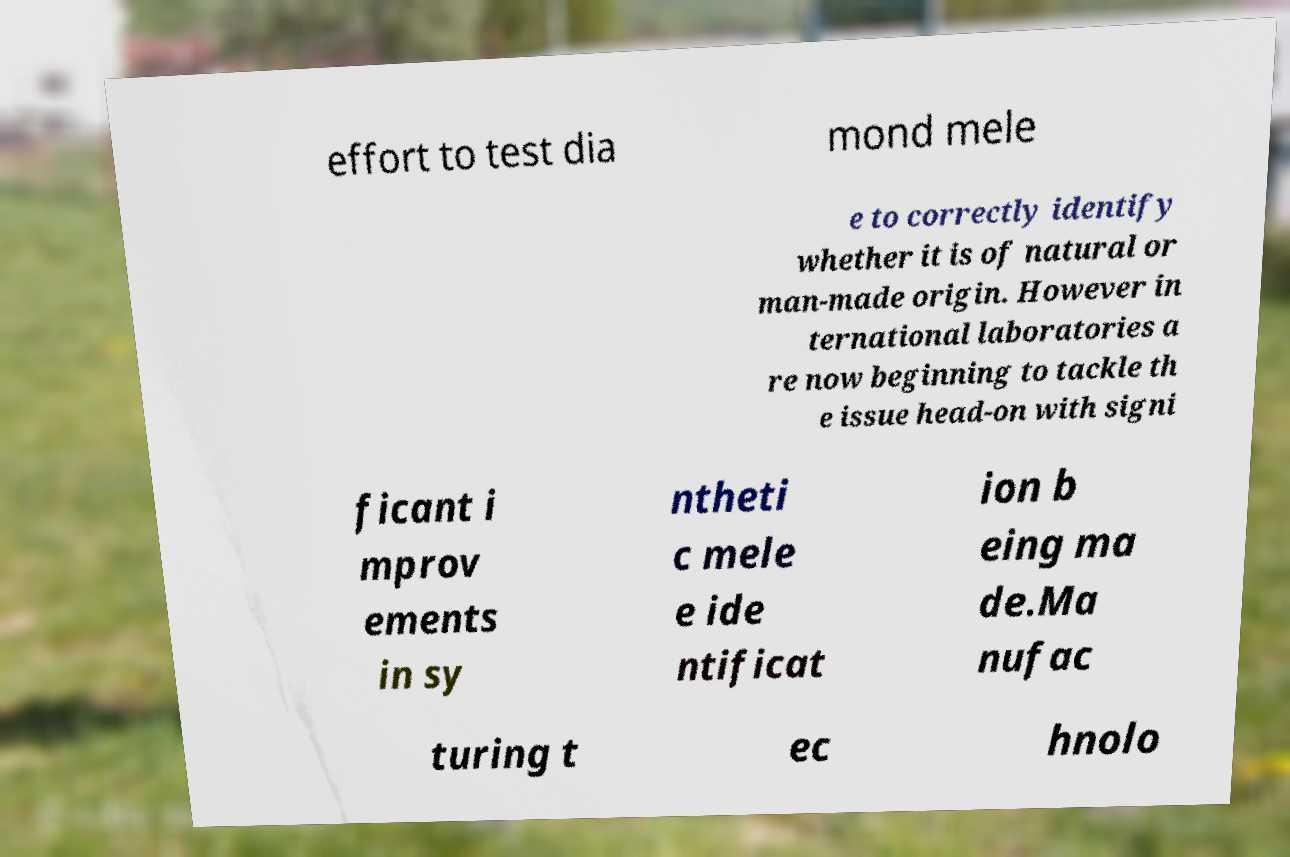Please identify and transcribe the text found in this image. effort to test dia mond mele e to correctly identify whether it is of natural or man-made origin. However in ternational laboratories a re now beginning to tackle th e issue head-on with signi ficant i mprov ements in sy ntheti c mele e ide ntificat ion b eing ma de.Ma nufac turing t ec hnolo 